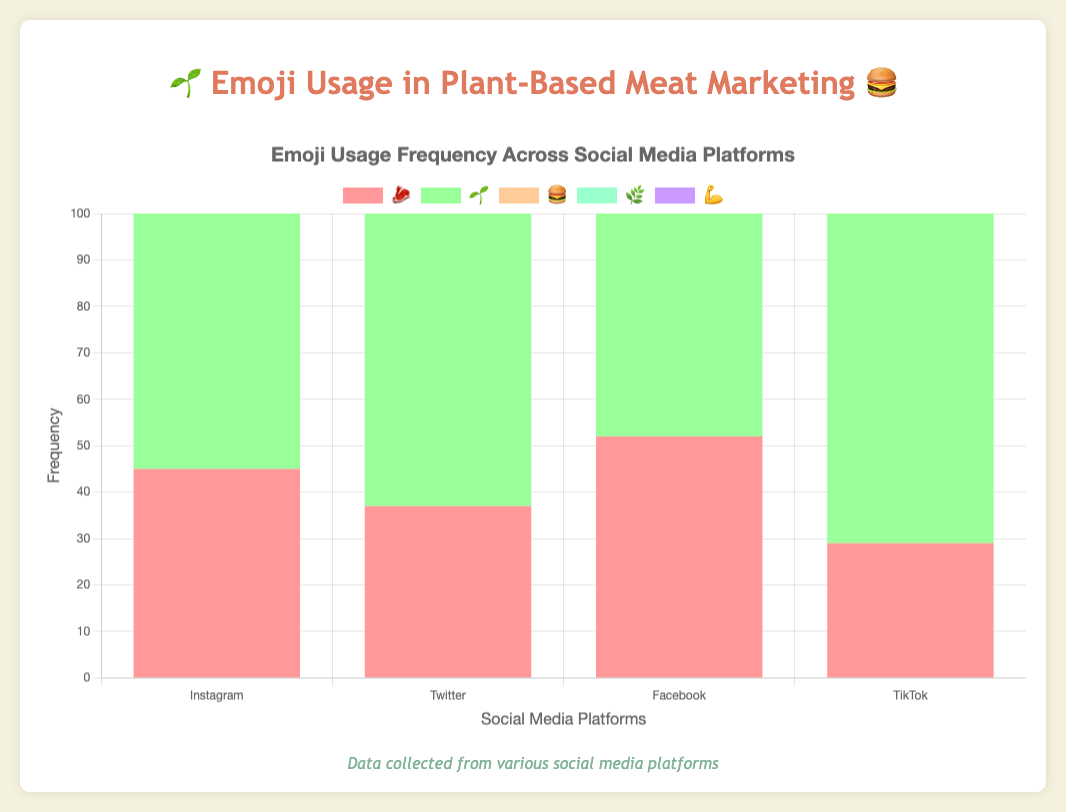Which emoji has the highest frequency on Instagram? The bar chart shows the frequencies of various emojis on each platform. For Instagram, the green bar representing the 🌱 emoji is the highest.
Answer: 🌱 Which emoji occurs most frequently on TikTok? By looking at the bar chart for TikTok, the green bar representing the 🌱 emoji is the tallest.
Answer: 🌱 How many more times is the 🌱 emoji used on Twitter compared to Facebook? The frequency of the 🌱 emoji on Twitter is 85, whereas on Facebook it is 67. Subtract 67 from 85 to get the difference.
Answer: 18 Which platform uses the 💪 emoji the least? The frequency of the 💪 emoji can be seen in the purple bars. The smallest purple bar among the platforms is on Facebook with a value of 33.
Answer: Facebook How does the frequency of the 🍔 emoji on Instagram compare with its frequency on TikTok? The frequency of the 🍔 emoji on Instagram is 62 and on TikTok, it is 76. TikTok has a higher frequency of 76 compared to Instagram's 62.
Answer: TikTok Which platform shows the highest combined frequency of the 🌱 and 🌿 emojis? Add the frequencies of 🌱 and 🌿 for each platform. Instagram: 78 + 53 = 131, Twitter: 85 + 49 = 134, Facebook: 67 + 44 = 111, TikTok: 92 + 61 = 153. TikTok has the highest combined frequency.
Answer: TikTok On which platform is the total usage of all emojis the lowest? Add all emoji frequencies for each platform. Instagram: 45 + 78 + 62 + 53 + 39 = 277, Twitter: 37 + 85 + 58 + 49 + 42 = 271, Facebook: 52 + 67 + 71 + 44 + 33 = 267, TikTok: 29 + 92 + 76 + 61 + 55 = 313. The lowest total is on Facebook.
Answer: Facebook What is the average frequency of the 🌿 emoji across all platforms? Sum the frequencies of 🌿 across platforms: 53 (Instagram) + 49 (Twitter) + 44 (Facebook) + 61 (TikTok) = 207. Divide by the number of platforms (4): 207 / 4 = 51.75.
Answer: 51.75 What is the most frequently used emoji on social media for plant-based meat marketing campaigns? Across all platforms, the highest frequency value appears for the 🌱 emoji on TikTok with a frequency of 92.
Answer: 🌱 